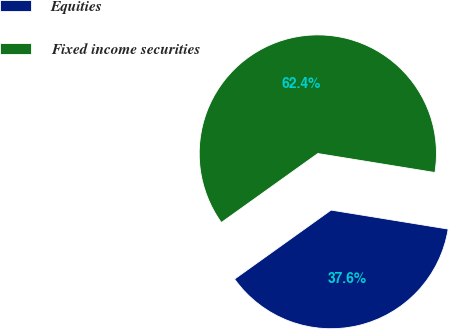Convert chart. <chart><loc_0><loc_0><loc_500><loc_500><pie_chart><fcel>Equities<fcel>Fixed income securities<nl><fcel>37.56%<fcel>62.44%<nl></chart> 